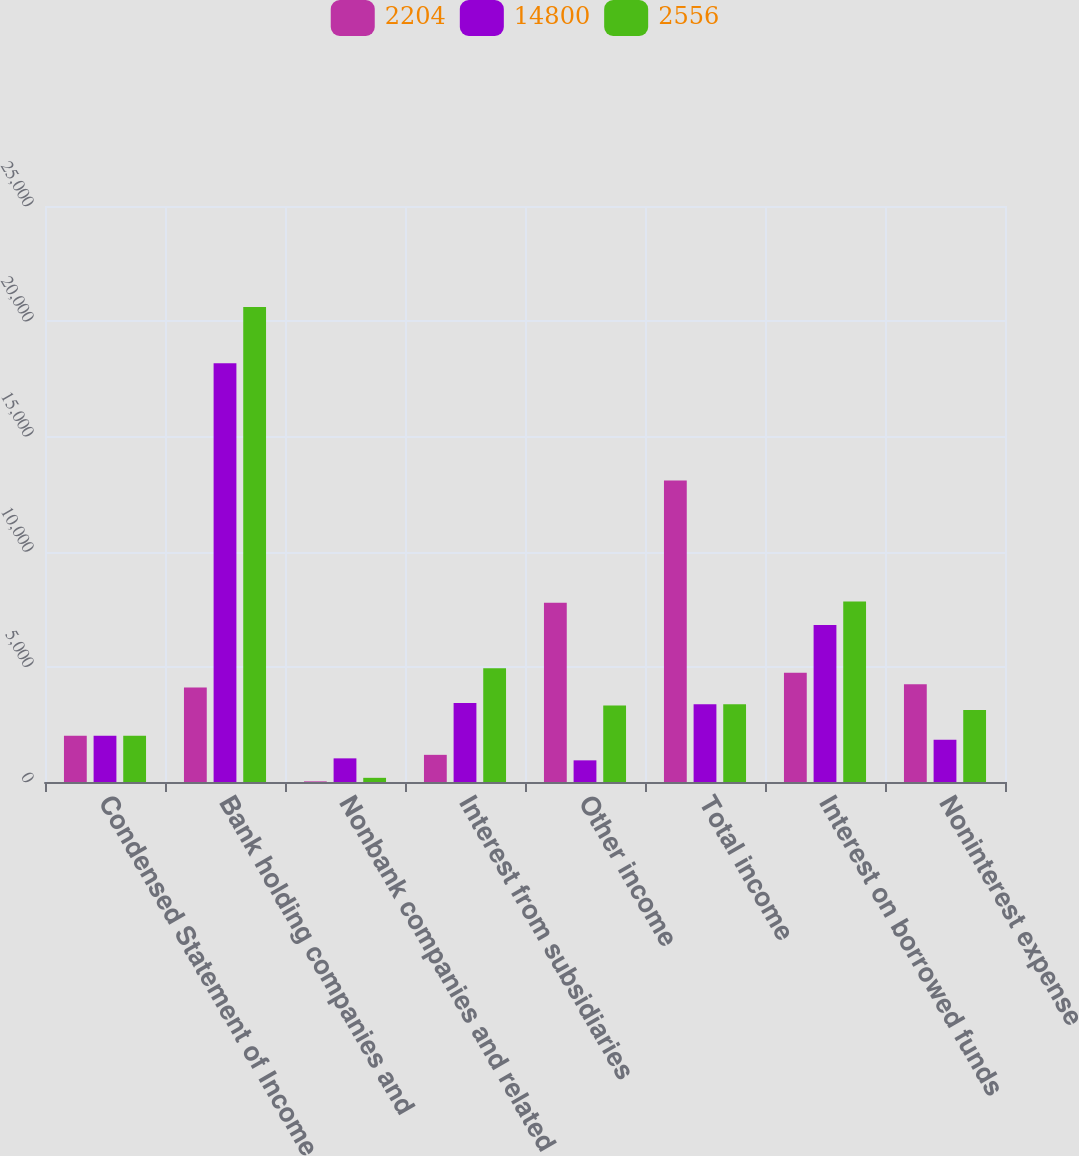Convert chart to OTSL. <chart><loc_0><loc_0><loc_500><loc_500><stacked_bar_chart><ecel><fcel>Condensed Statement of Income<fcel>Bank holding companies and<fcel>Nonbank companies and related<fcel>Interest from subsidiaries<fcel>Other income<fcel>Total income<fcel>Interest on borrowed funds<fcel>Noninterest expense<nl><fcel>2204<fcel>2009<fcel>4100<fcel>27<fcel>1179<fcel>7784<fcel>13090<fcel>4737<fcel>4238<nl><fcel>14800<fcel>2008<fcel>18178<fcel>1026<fcel>3433<fcel>940<fcel>3376<fcel>6818<fcel>1829<nl><fcel>2556<fcel>2007<fcel>20615<fcel>181<fcel>4939<fcel>3319<fcel>3376<fcel>7834<fcel>3127<nl></chart> 